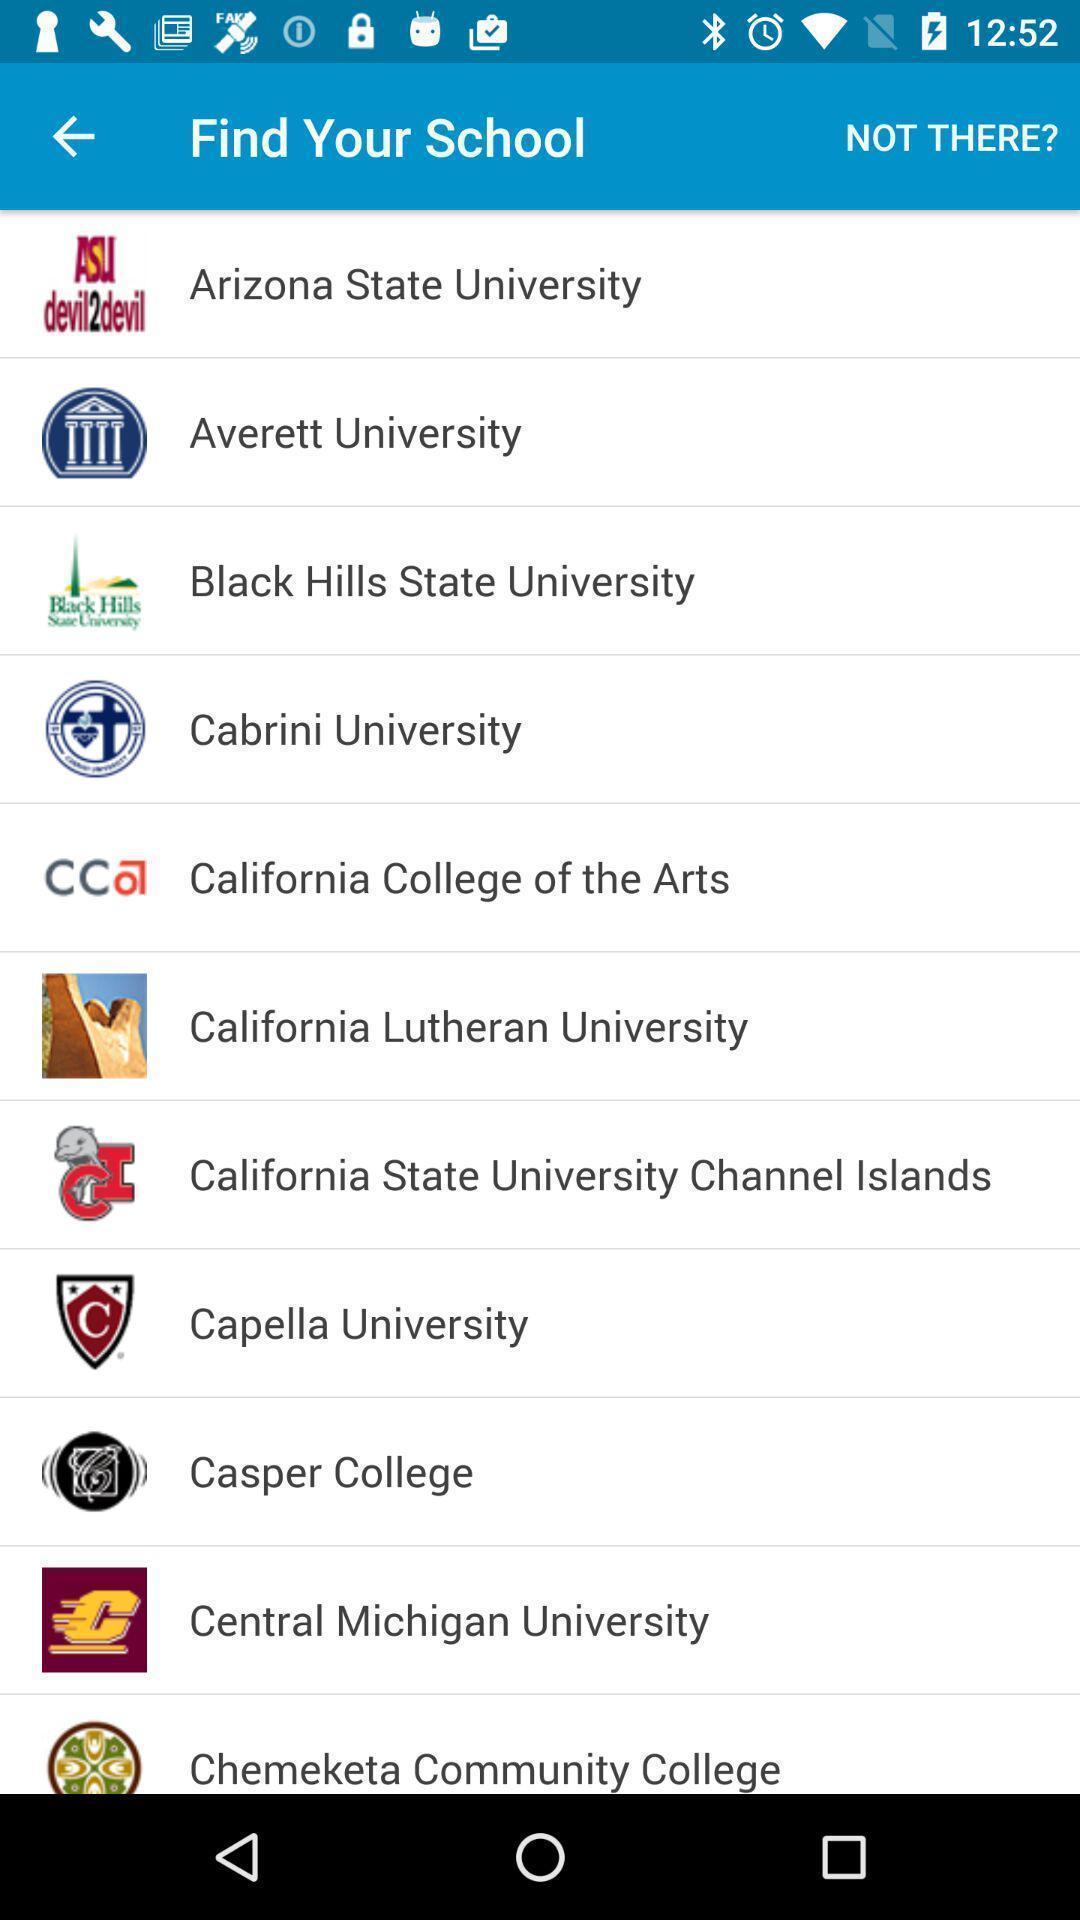Describe the content in this image. Screen displaying list of different schools with names. 